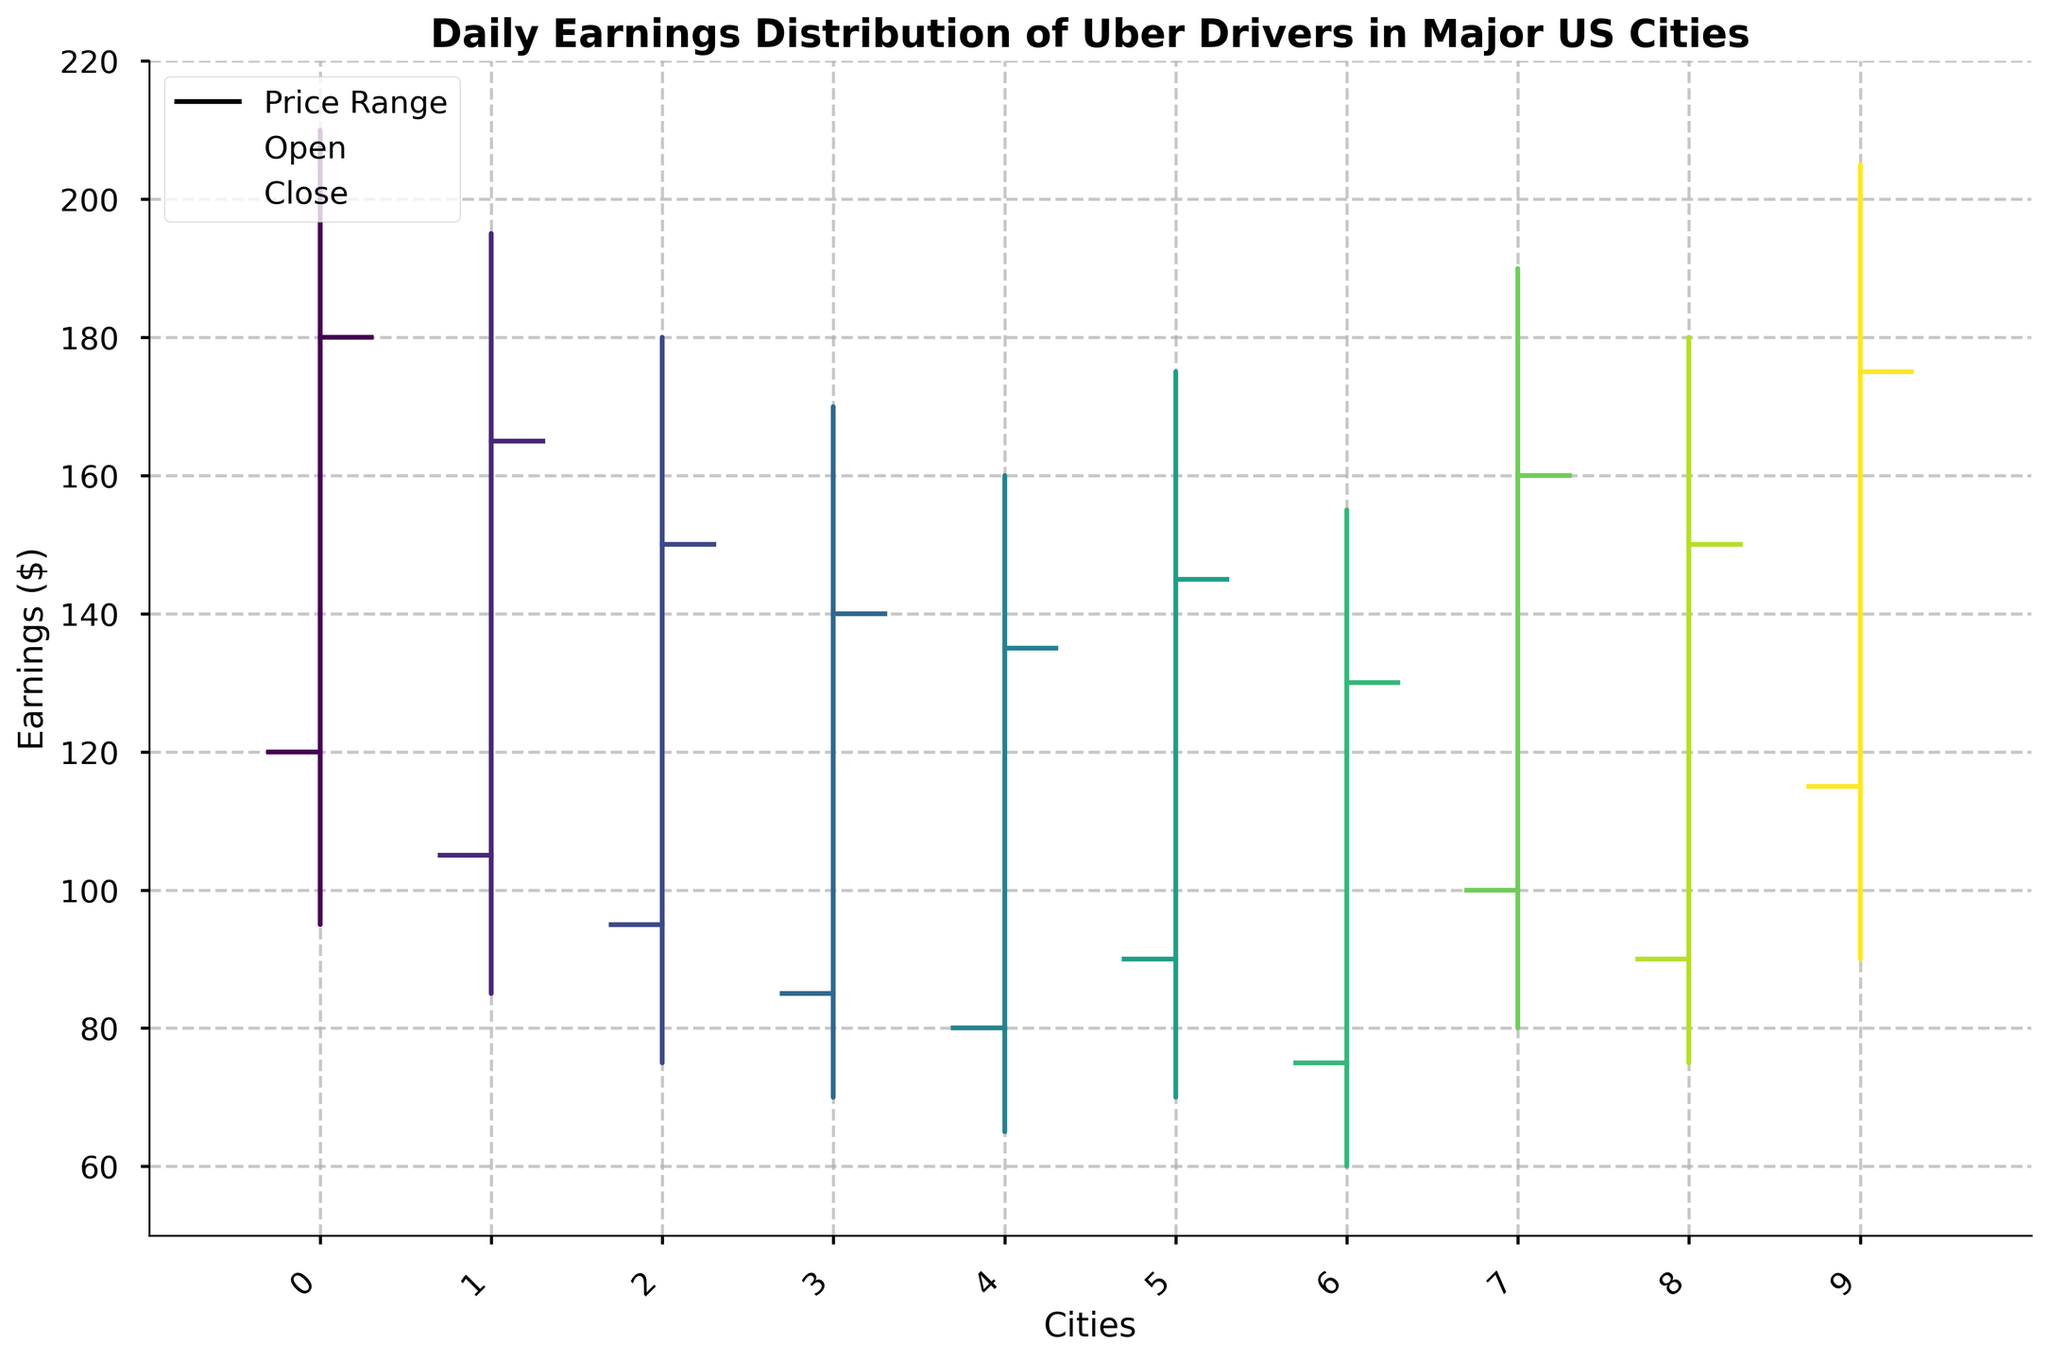What's the highest daily earning in the dataset? The highest daily earning is represented by the highest "High" value in the chart, which for New York City is $210
Answer: $210 Which city has the smallest range of daily earnings? The range is calculated by subtracting the "Low" from the "High" earnings for each city. New York City has the smallest range: 210 - 95 = 115
Answer: New York City Which city has the lowest opening earnings? The "Open" value represents the opening earnings. San Antonio has the lowest opening earnings of $75
Answer: San Antonio How do you interpret a large difference between the open and close earnings? A large difference between open and close earnings can suggest high volatility or significant earnings changes during the day. For instance, in New York City, the open is $120 and the close is $180, indicating earnings increased
Answer: High volatility or significant earnings increase/decrease What’s the median value of the low earnings across all cities? First, list all the "Low" values: 95, 85, 75, 70, 65, 70, 60, 80, 75, 90. Sorting them: 60, 65, 70, 70, 75, 75, 80, 85, 90, 95. The median is the average of the 5th and 6th values: (75 + 75) / 2 = 75
Answer: $75 Which city has the closest closing earnings to its opening earnings? By comparing the differences between "Open" and "Close" values, San Diego has the smallest difference: $100 - $160 = $60
Answer: San Diego What is the range of daily earnings for drivers in Phoenix? The range is the "High" value minus the "Low" value. For Phoenix, this is 160 - 65 = 95
Answer: $95 Compare the opening earnings of San Jose and New York City. Which one is higher? The "Open" earnings in New York City is $120 and in San Jose is $115, so New York City's opening earnings are higher
Answer: New York City's How many cities have their closing earnings higher than their opening earnings? By comparing the "Open" and "Close" values for each city: New York City, Los Angeles, Philadelphia, San Diego, San Jose all have closing earnings higher than their opening earnings (5 cities)
Answer: 5 cities Which city has the highest closing earnings, and what is that value? The "Close" values indicate the closing earnings. New York City has the highest closing earnings at $180
Answer: New York City 